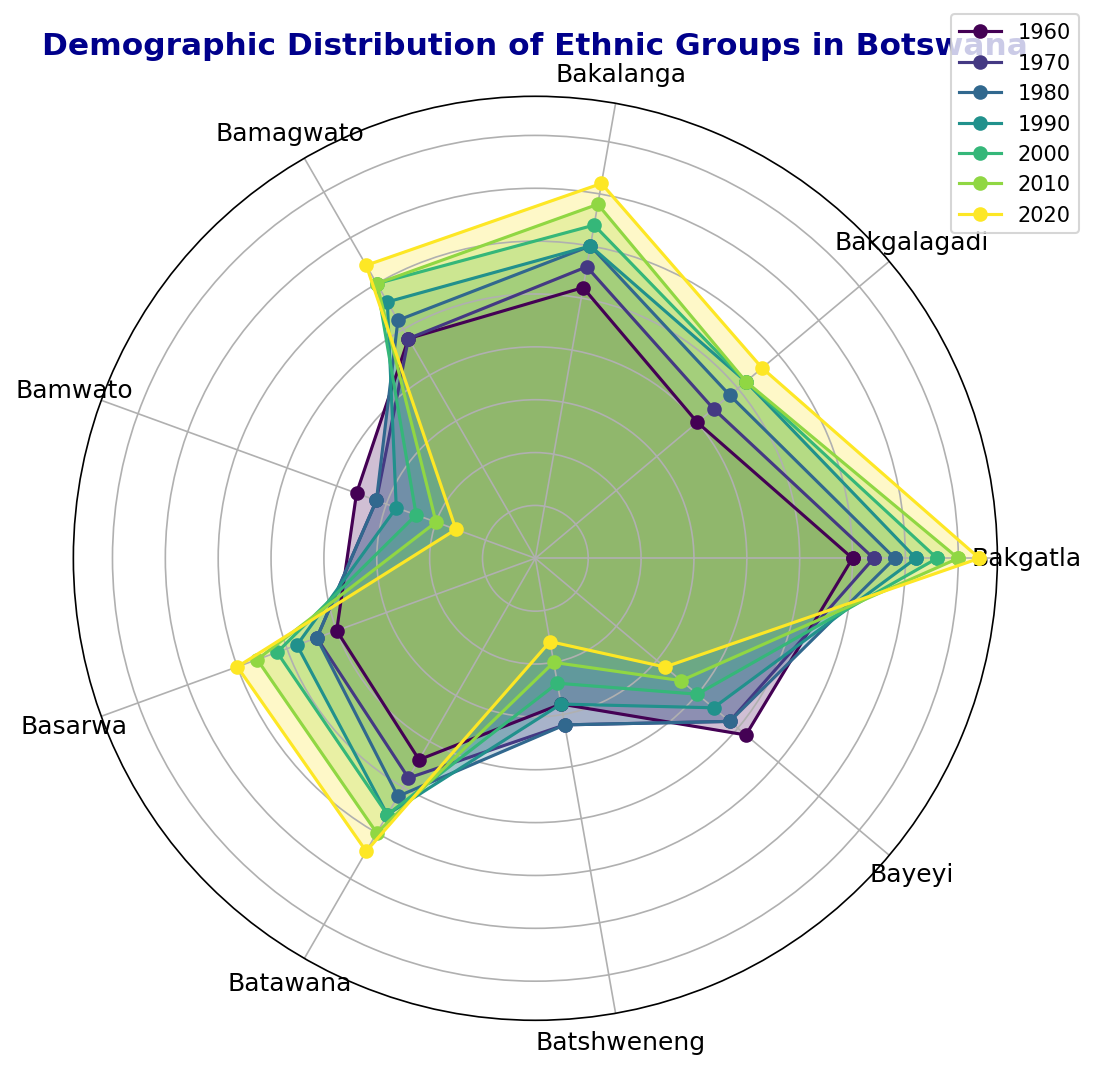What's the highest percentage value for the Bakalanga group? Look at the Bakalanga group across all decades. The highest percentage value is in 2020, which is 18%.
Answer: 18 Which group saw a decrease in percentage from 1960 to 2020? Compare the values for each group in 1960 and 2020. Bakgatla, Bakalanga, Bamagwato, and Batawana all increased. Bakgalagadi increased slightly. Basarwa and Bayeyi also increased. Bamwato and Batshweneng decreased from 9 to 4 and 7 to 4, respectively.
Answer: Bamwato, Batshweneng What is the average percentage value for the Batawana group across all decades? Sum up the values for Batawana (11 + 12 + 13 + 14 + 14 + 15 + 16 = 95) and divide by the number of decades (7). 95/7 ≈ 13.57.
Answer: 13.57 Which group had the lowest percentage in 2010? Look at the percentages for all groups in 2010. Bamwato has the lowest value at 5%.
Answer: Bamwato Did the percentage of the Bakgatla group increase or decrease over the decades? Look at the values for Bakgatla from 1960 to 2020 (15, 16, 17, 18, 19, 20, 21). The values consistently increased.
Answer: Increase Which group had a higher percentage in 1980: Bakgalagadi or Batshweneng? Look at the values for Bakgalagadi and Batshweneng in 1980. Bakgalagadi is 12, Batshweneng is 8. Bakgalagadi has a higher percentage.
Answer: Bakgalagadi By how much did the percentage of the Basarwa group change from 1960 to 2000? Subtract the value of Basarwa in 1960 (10) from the value in 2000 (13). 13 - 10 = 3
Answer: 3 Which decade shows the highest percentage for the Bamagwato group? Look at the values for Bamagwato across all decades. The highest value is in 2020, which is 16.
Answer: 2020 Which two groups had the same percentage in any decade? Compare the values of all groups across the decades; in 2010, Bamagwato and Bakgalagadi both have a percentage of 13.
Answer: Bamagwato, Bakgalagadi 